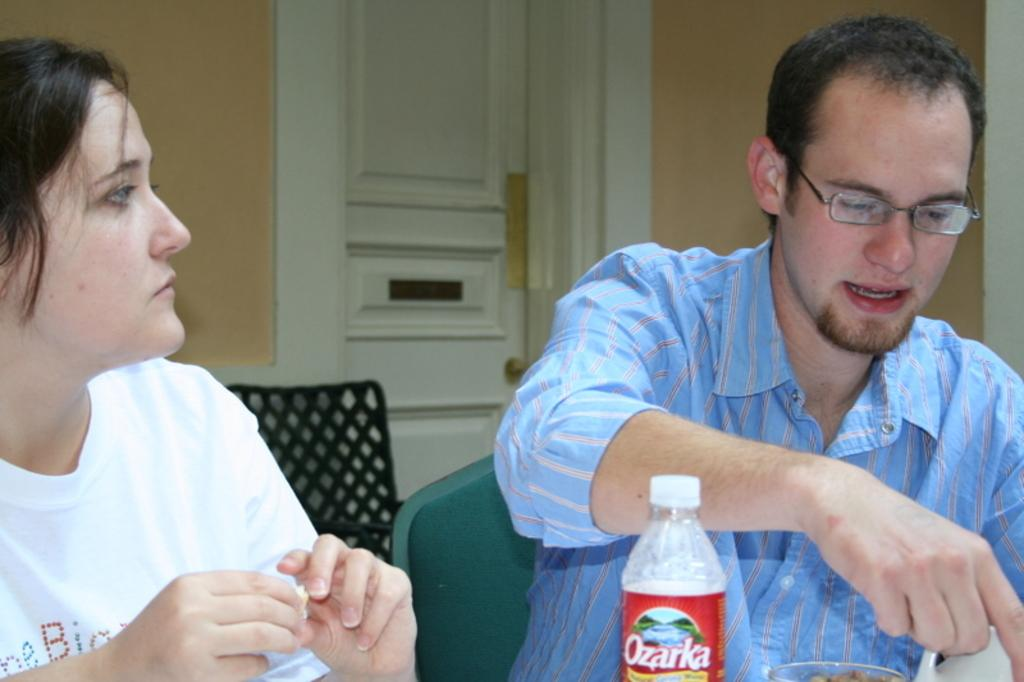Who is present in the image? There is a man and a woman in the image. What are the man and woman doing in the image? Both the man and woman are seated on chairs. What object can be seen in the image besides the man and woman? There is a bottle visible in the image. What architectural feature is present in the image? There is a door in the image. What type of knot is the man tying in the image? There is no knot-tying activity present in the image; the man is simply seated on a chair. 